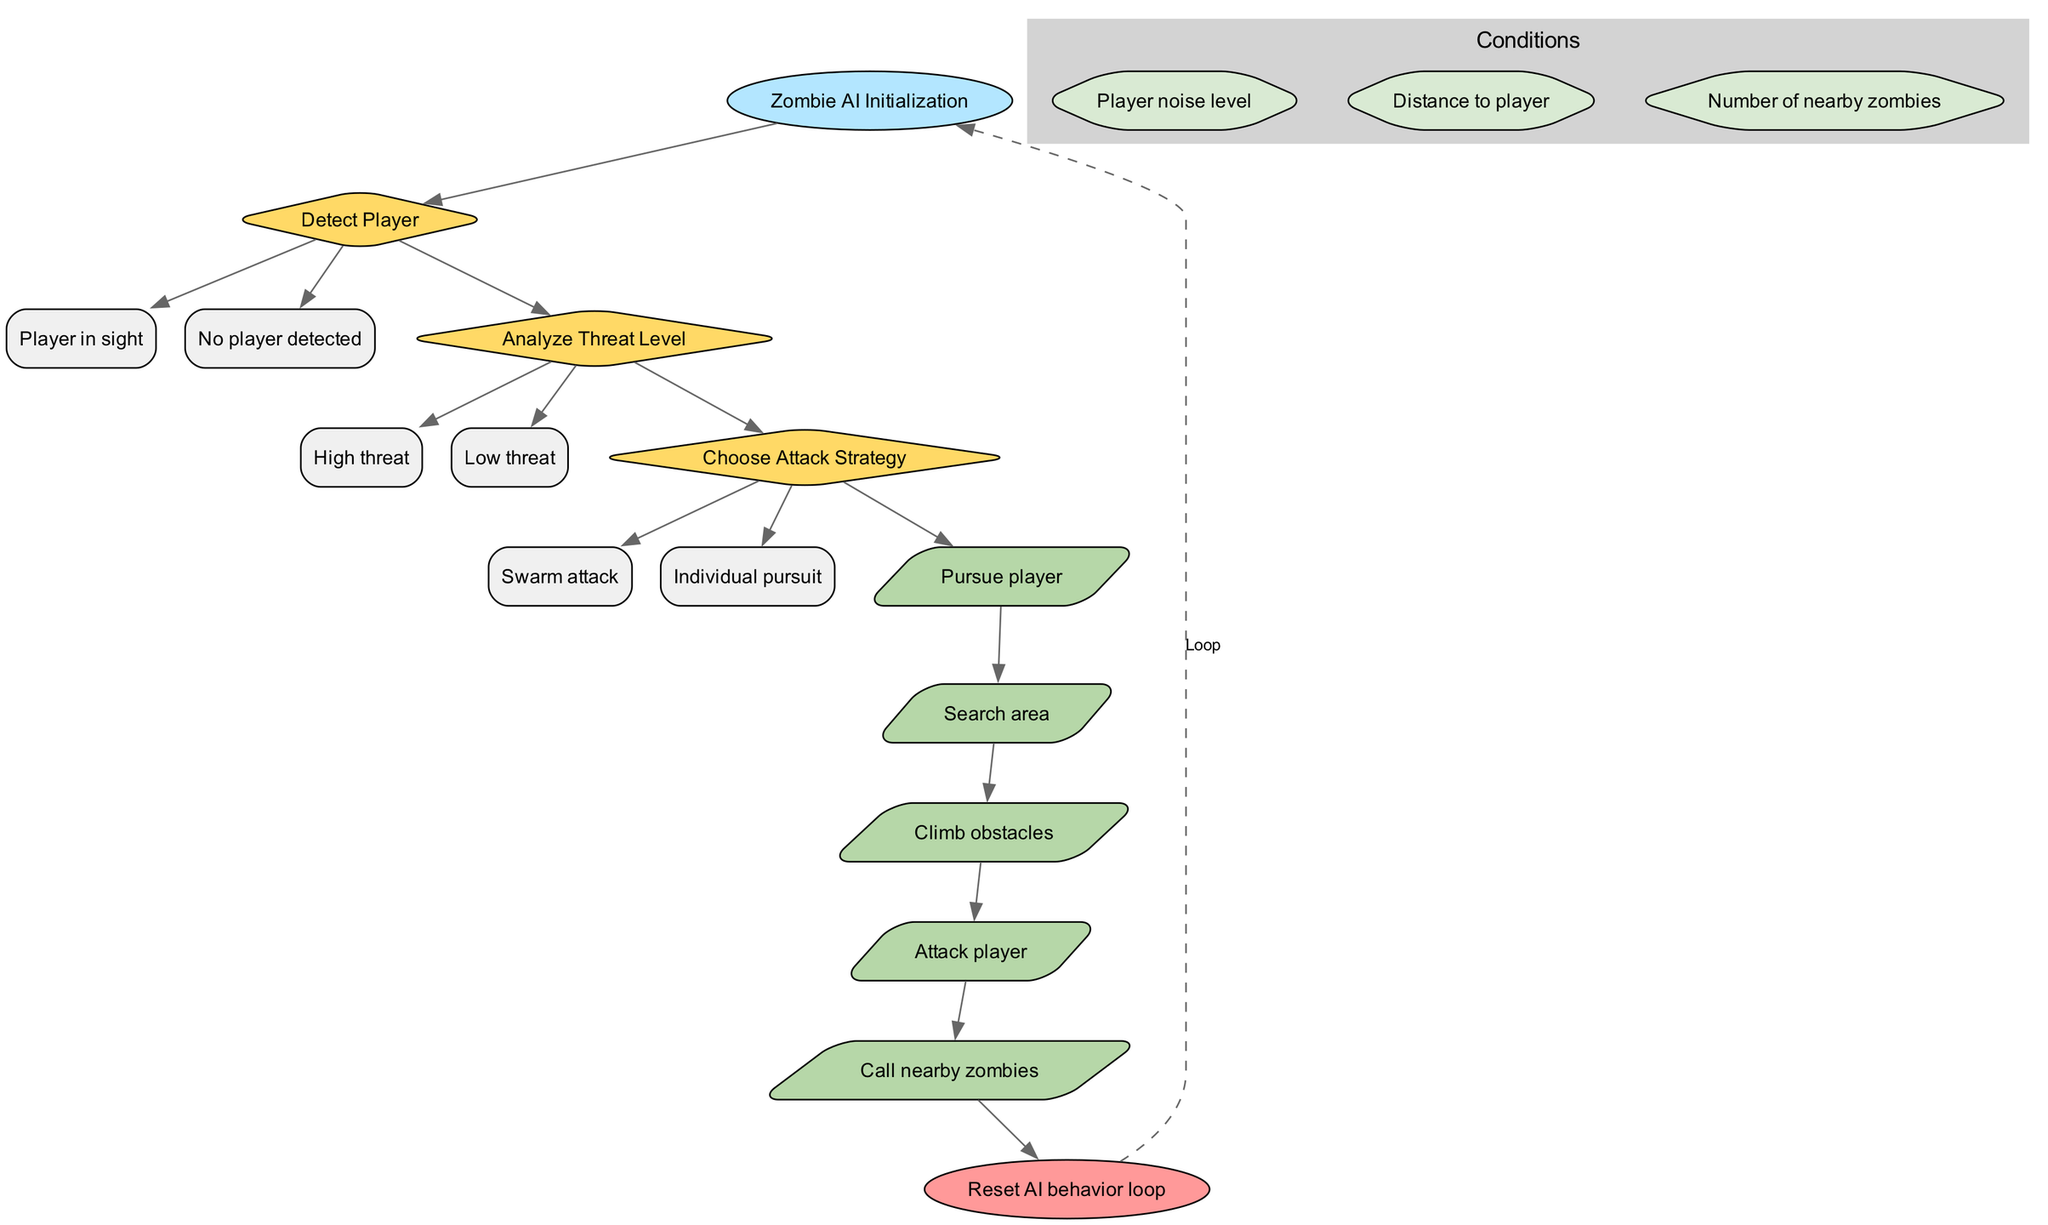What is the first process in the flowchart? The first process listed is "Zombie AI Initialization," which starts the flowchart indicating where the AI system begins its operations.
Answer: Zombie AI Initialization How many decision points are there in the diagram? There are three decision points: "Detect Player," "Analyze Threat Level," and "Choose Attack Strategy," representing key choices in the zombie AI behavior.
Answer: 3 What happens after "Detect Player" when a player is in sight? If a player is in sight, the next step is to "Analyze Threat Level," continuing the decision-making process based on player detection.
Answer: Analyze Threat Level If the threat level is high, what action is taken? A high threat level leads to the action "Call nearby zombies," indicating that the zombie AI decides to reinforce its attack strategy by summoning others.
Answer: Call nearby zombies What structure is used for the actions in the flowchart? The actions are represented as parallelograms in the flowchart, which is a standard shape used to denote operations or processes performed in system diagrams.
Answer: Parallelogram What condition can influence the zombie AI's decision to attack? The "Distance to player" is a condition that affects whether the zombie AI chooses to pursue or attack the player, impacting the AI's tactical approach.
Answer: Distance to player Which node connects the actions to the end of the flowchart? The node connecting the final action, "Attack player," to the "end" node is crucial as it indicates that successful action leads to the completion of the AI behavior loop.
Answer: Attack player What is the loop's structure that leads back to the start node? The flowchart indicates a dashed edge that connects the "end" node back to the "start" node, signifying that the AI behavior is cyclical and resets after completing its actions.
Answer: Dashed edge What is the color scheme used for decision nodes? Decision nodes are colored yellow (fillcolor #ffd966) in the diagram, distinguishing them from other types of nodes and highlighting their role in the zombie AI decision-making process.
Answer: Yellow 